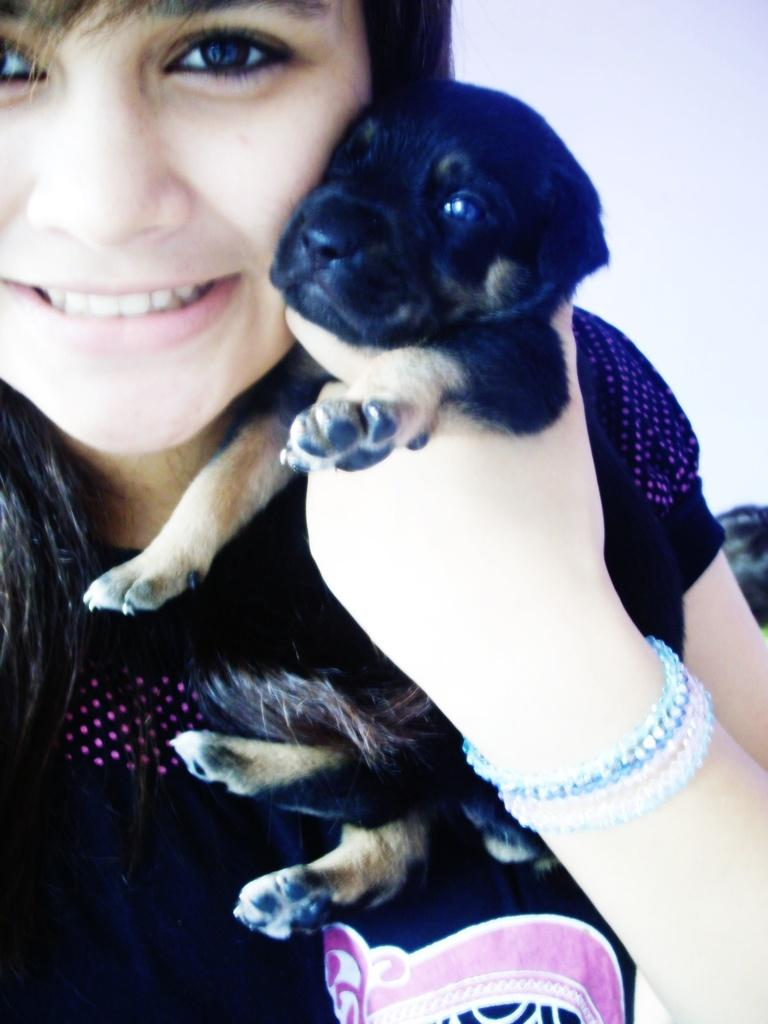Who is the main subject in the image? There is a woman in the image. What is the woman holding in her hand? The woman is holding a dog in her hand. What expression does the woman have? The woman is smiling. How much of the woman's face can be seen in the image? The woman's face is half visible. What can be seen in the background of the image? The sky is visible in the image. What is the color of the sky in the image? The color of the sky is blue. What type of garden can be seen in the image? There is no garden present in the image. What color is the woman's dress in the image? The provided facts do not mention the color of the woman's dress, so it cannot be determined from the image. 